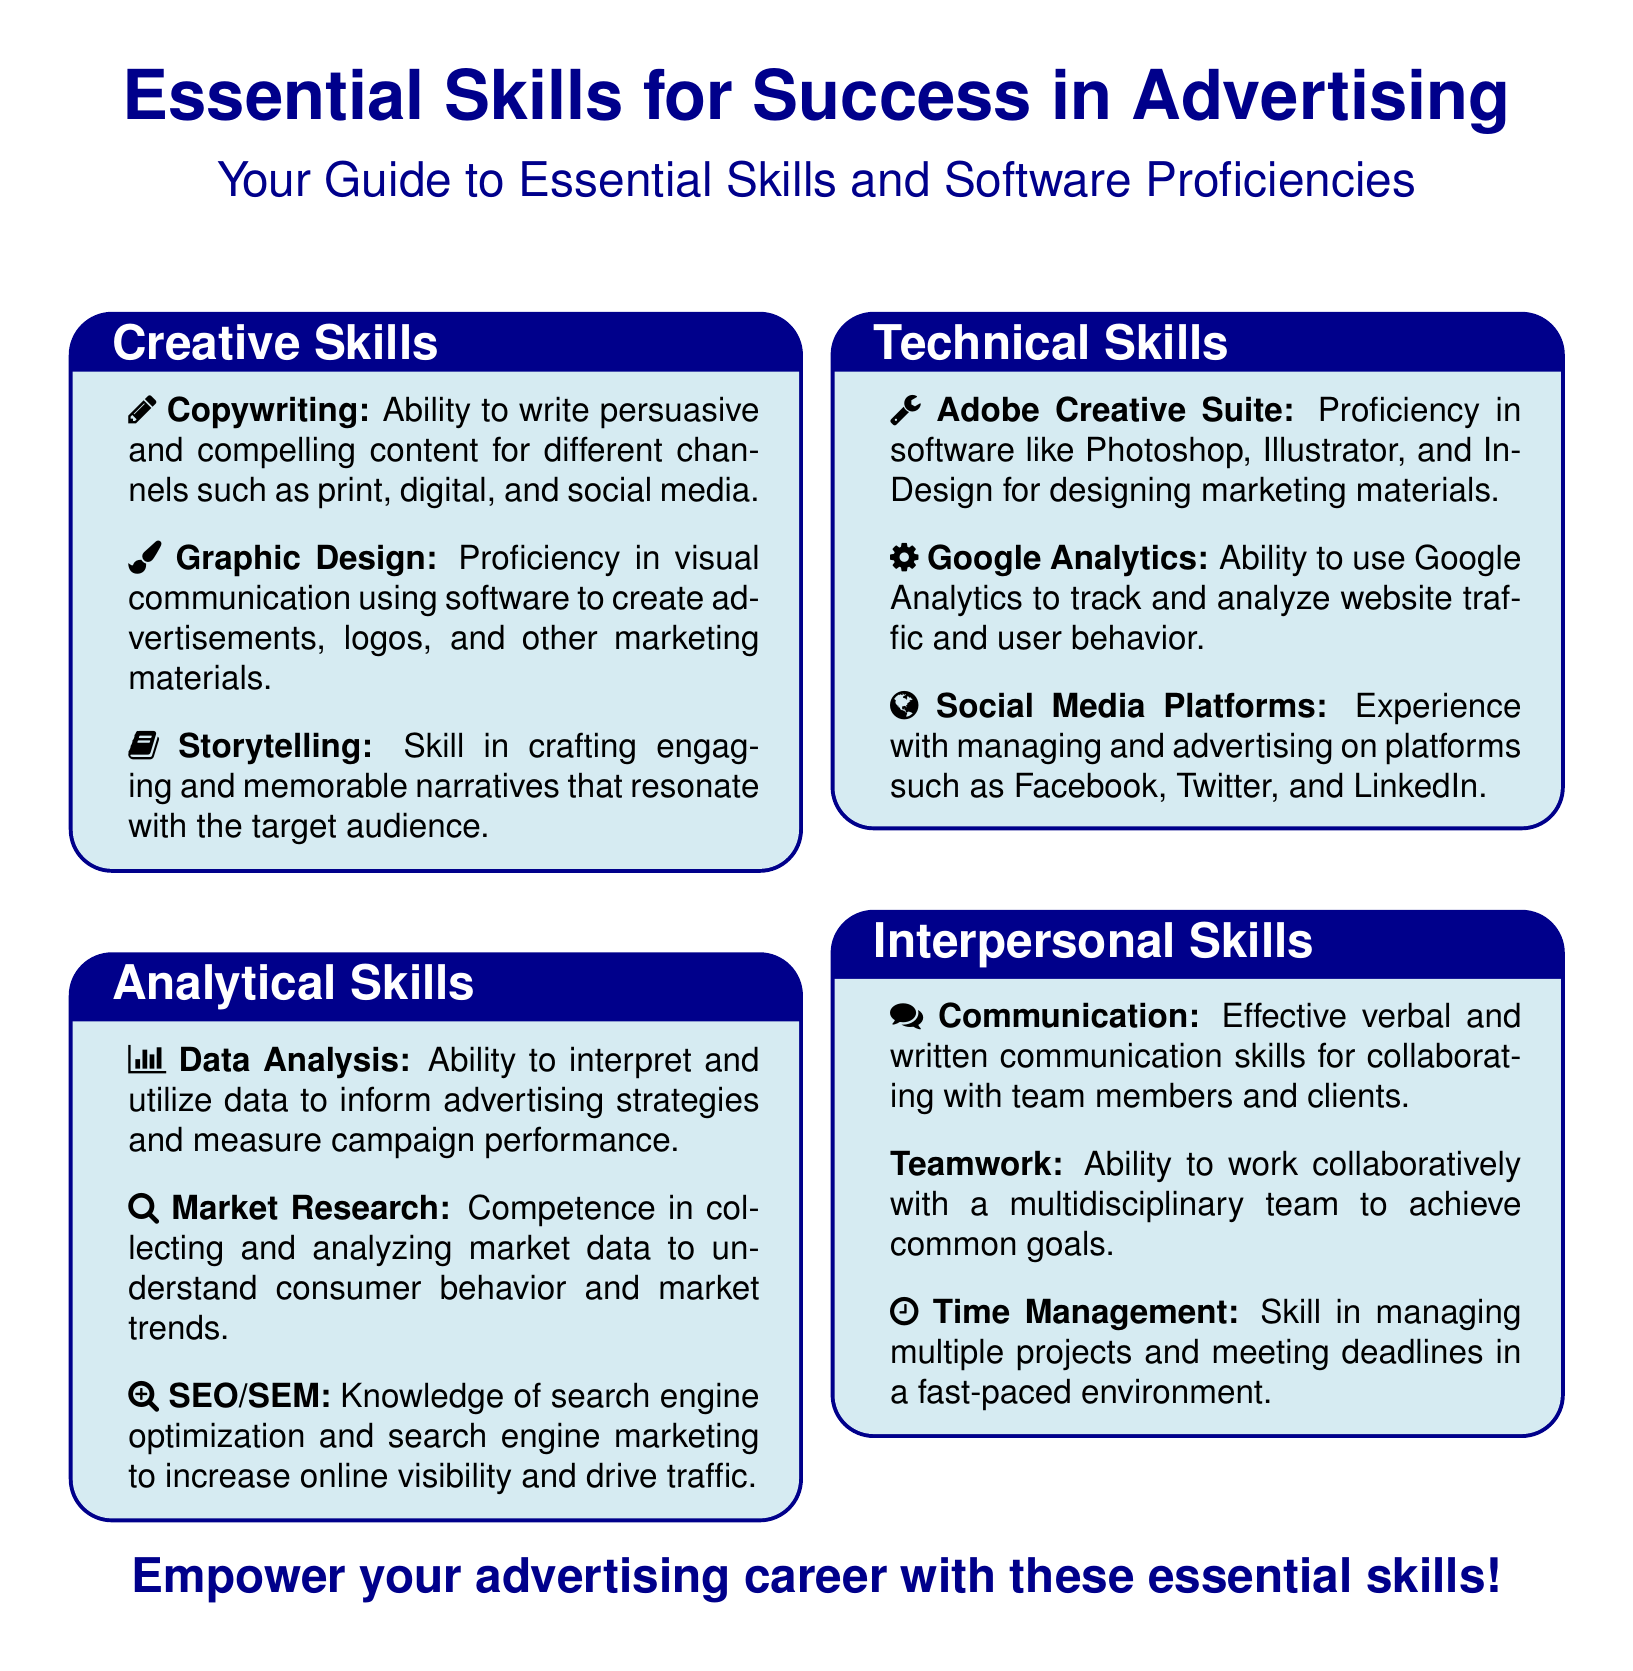What are the four main skill categories in advertising? The flyer lists four main skill categories: Creative Skills, Analytical Skills, Technical Skills, and Interpersonal Skills.
Answer: Creative Skills, Analytical Skills, Technical Skills, Interpersonal Skills What software is mentioned for graphic design? Adobe Creative Suite is noted as proficiency required for graphic design tasks.
Answer: Adobe Creative Suite Which skill involves crafting narratives? Storytelling is the listed skill that involves crafting engaging narratives.
Answer: Storytelling How many skills are listed under the Analytical Skills category? There are three specific skills outlined under the Analytical Skills category: Data Analysis, Market Research, and SEO/SEM.
Answer: Three What type of communication skill is highlighted in the Interpersonal Skills section? The document highlights Effective verbal and written communication as a key skill under Interpersonal Skills.
Answer: Communication Which software tool is used to track website traffic? Google Analytics is identified as the software used for tracking website traffic and user behavior.
Answer: Google Analytics What icon represents copywriting in the document? The pencil icon represents copywriting in the skills section.
Answer: Pencil Which interpersonal skill is related to managing multiple projects? Time Management is mentioned as the skill related to managing multiple projects.
Answer: Time Management What is the overall theme of the flyer? The flyer emphasizes empowering individuals for success in the advertising career through essential skills.
Answer: Empower your advertising career with these essential skills! 